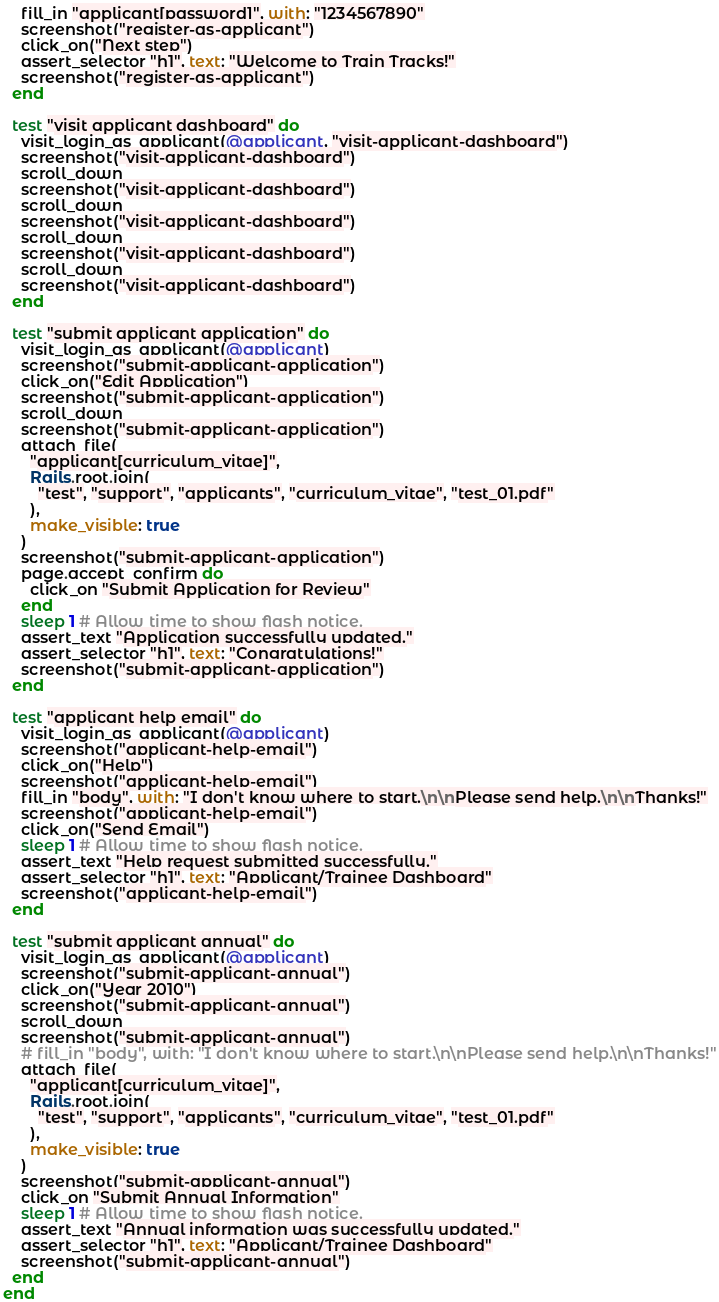<code> <loc_0><loc_0><loc_500><loc_500><_Ruby_>    fill_in "applicant[password]", with: "1234567890"
    screenshot("register-as-applicant")
    click_on("Next step")
    assert_selector "h1", text: "Welcome to Train Tracks!"
    screenshot("register-as-applicant")
  end

  test "visit applicant dashboard" do
    visit_login_as_applicant(@applicant, "visit-applicant-dashboard")
    screenshot("visit-applicant-dashboard")
    scroll_down
    screenshot("visit-applicant-dashboard")
    scroll_down
    screenshot("visit-applicant-dashboard")
    scroll_down
    screenshot("visit-applicant-dashboard")
    scroll_down
    screenshot("visit-applicant-dashboard")
  end

  test "submit applicant application" do
    visit_login_as_applicant(@applicant)
    screenshot("submit-applicant-application")
    click_on("Edit Application")
    screenshot("submit-applicant-application")
    scroll_down
    screenshot("submit-applicant-application")
    attach_file(
      "applicant[curriculum_vitae]",
      Rails.root.join(
        "test", "support", "applicants", "curriculum_vitae", "test_01.pdf"
      ),
      make_visible: true
    )
    screenshot("submit-applicant-application")
    page.accept_confirm do
      click_on "Submit Application for Review"
    end
    sleep 1 # Allow time to show flash notice.
    assert_text "Application successfully updated."
    assert_selector "h1", text: "Congratulations!"
    screenshot("submit-applicant-application")
  end

  test "applicant help email" do
    visit_login_as_applicant(@applicant)
    screenshot("applicant-help-email")
    click_on("Help")
    screenshot("applicant-help-email")
    fill_in "body", with: "I don't know where to start.\n\nPlease send help.\n\nThanks!"
    screenshot("applicant-help-email")
    click_on("Send Email")
    sleep 1 # Allow time to show flash notice.
    assert_text "Help request submitted successfully."
    assert_selector "h1", text: "Applicant/Trainee Dashboard"
    screenshot("applicant-help-email")
  end

  test "submit applicant annual" do
    visit_login_as_applicant(@applicant)
    screenshot("submit-applicant-annual")
    click_on("Year 2010")
    screenshot("submit-applicant-annual")
    scroll_down
    screenshot("submit-applicant-annual")
    # fill_in "body", with: "I don't know where to start.\n\nPlease send help.\n\nThanks!"
    attach_file(
      "applicant[curriculum_vitae]",
      Rails.root.join(
        "test", "support", "applicants", "curriculum_vitae", "test_01.pdf"
      ),
      make_visible: true
    )
    screenshot("submit-applicant-annual")
    click_on "Submit Annual Information"
    sleep 1 # Allow time to show flash notice.
    assert_text "Annual information was successfully updated."
    assert_selector "h1", text: "Applicant/Trainee Dashboard"
    screenshot("submit-applicant-annual")
  end
end
</code> 